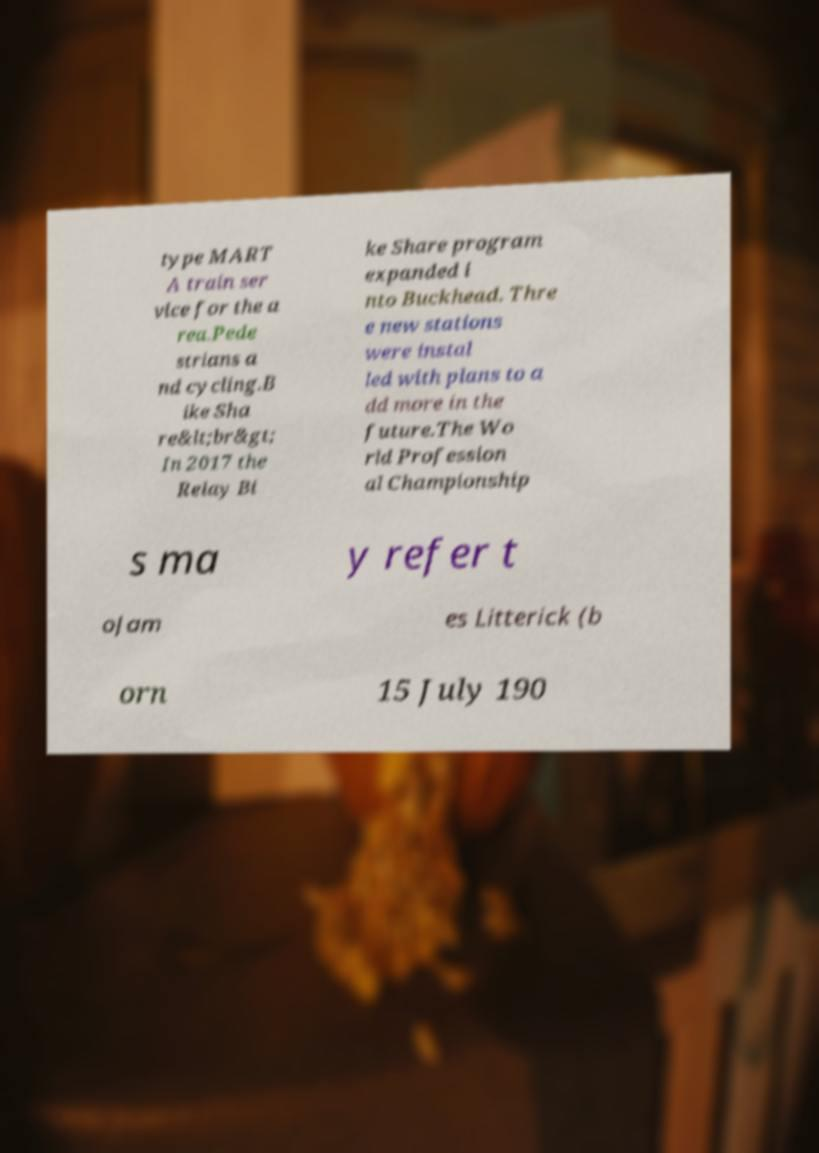Could you assist in decoding the text presented in this image and type it out clearly? type MART A train ser vice for the a rea.Pede strians a nd cycling.B ike Sha re&lt;br&gt; In 2017 the Relay Bi ke Share program expanded i nto Buckhead. Thre e new stations were instal led with plans to a dd more in the future.The Wo rld Profession al Championship s ma y refer t oJam es Litterick (b orn 15 July 190 